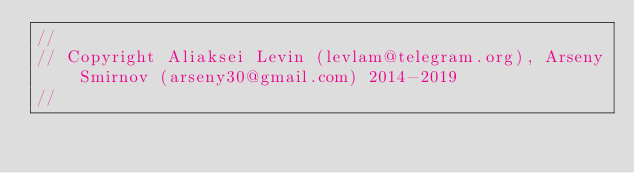<code> <loc_0><loc_0><loc_500><loc_500><_C++_>//
// Copyright Aliaksei Levin (levlam@telegram.org), Arseny Smirnov (arseny30@gmail.com) 2014-2019
//</code> 